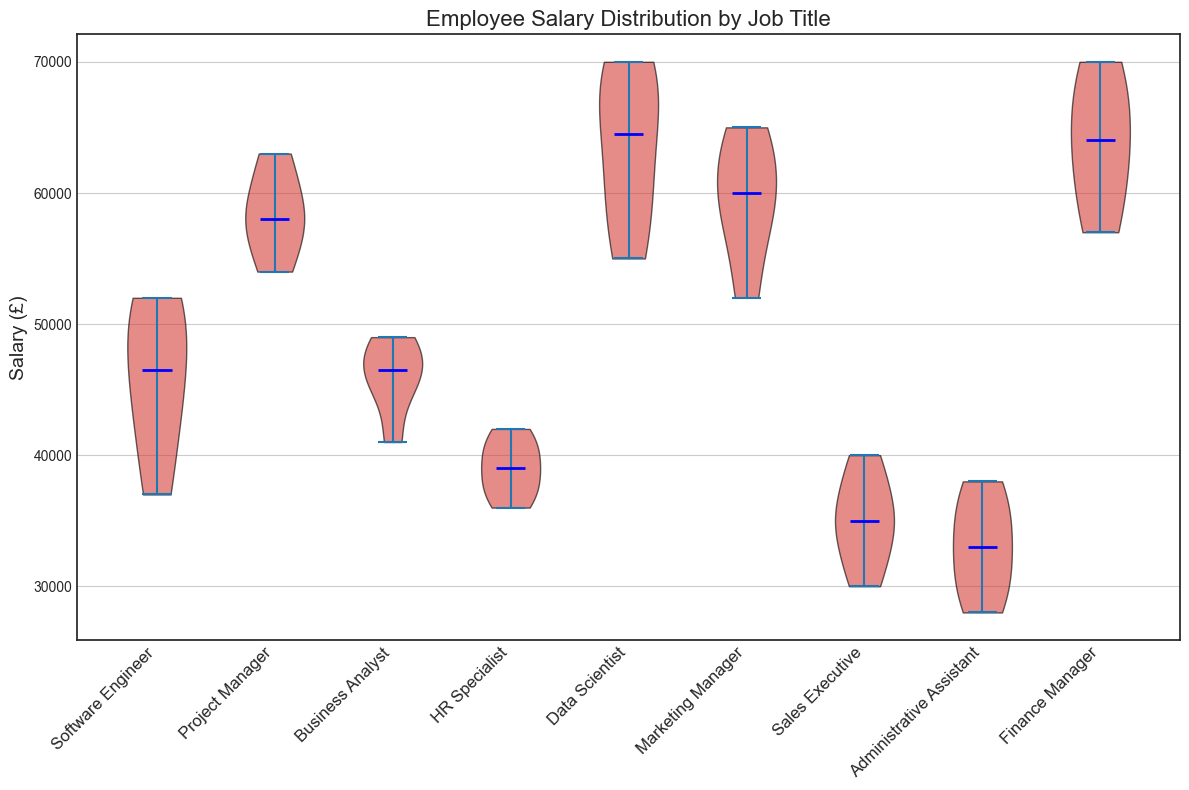Which job title has the highest median salary? The violet plot shows the medians for each job title in blue. By examining the medians, the job title with the highest median salary can be identified.
Answer: Data Scientist Which job title has the lowest median salary? Look at the blue lines (medians) on the violin plot; identify the job title with the lowest median.
Answer: Administrative Assistant What's the range of the salaries for Software Engineers? Find the maximum and minimum points within the violin plot for Software Engineers. The range is the difference between the highest and lowest salaries.
Answer: £15,000 Which job title has the widest salary distribution? The job title with the broadest spread on the y-axis of the violin plot will have the widest distribution.
Answer: Data Scientist Compare the median salaries of Project Managers and Marketing Managers. Which one is higher? Locate the blue median line for both Project Managers and Marketing Managers and compare their positions.
Answer: Project Managers What is the average salary for Sales Executives based on the visual distribution? Estimate the average from the central tendency of the red-area spread out in the violin plot for Sales Executives. This can be tricky visually but involves approximating the middle of the distribution.
Answer: £35,000 Between HR Specialists and Business Analysts, who has a higher maximum salary? Observe the highest points in the violin plots for both HR Specialists and Business Analysts, then compare.
Answer: Business Analyst Which job titles have interquartile ranges (IQR) that are relatively small? Identify job titles with narrow horizontal spreads (the thickness) around the median in the violin plot, indicating a smaller IQR.
Answer: Sales Executives, Administrative Assistant, HR Specialist Which job titles have overlapping salary distributions? Look for the red areas of the violin plots that overlap each other significantly when placed side by side.
Answer: Project Manager and Data Scientist If a salary of £45,000 is considered as a benchmark, which job titles have the majority of employees earning below this amount? Check the main body of the violin plots that are below the £45,000 line for each job title.
Answer: Sales Executives, Administrative Assistant, HR Specialist 